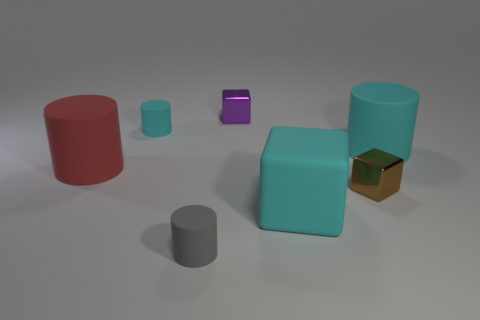Subtract all big red cylinders. How many cylinders are left? 3 Subtract all cyan cylinders. How many cylinders are left? 2 Subtract 1 red cylinders. How many objects are left? 6 Subtract all cylinders. How many objects are left? 3 Subtract 1 cylinders. How many cylinders are left? 3 Subtract all blue blocks. Subtract all blue spheres. How many blocks are left? 3 Subtract all yellow blocks. How many cyan cylinders are left? 2 Subtract all tiny gray rubber objects. Subtract all big red cylinders. How many objects are left? 5 Add 2 big cyan objects. How many big cyan objects are left? 4 Add 4 brown shiny cubes. How many brown shiny cubes exist? 5 